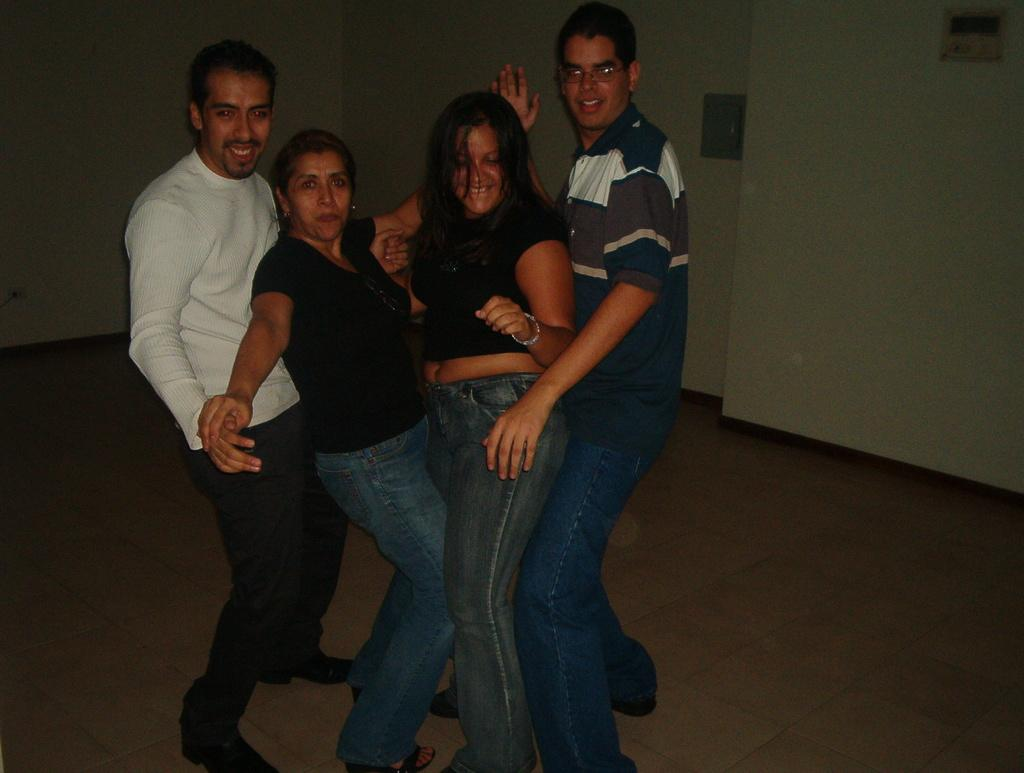What can be seen in the image? There are people standing in the image. Where are the people standing? The people are standing on the floor. What can be seen in the background of the image? There is a wall visible in the background of the image, and there are objects present in the background as well. What type of animal is sleeping on the bed in the image? There is no animal or bed present in the image; it only features people standing on the floor with a wall and objects visible in the background. 